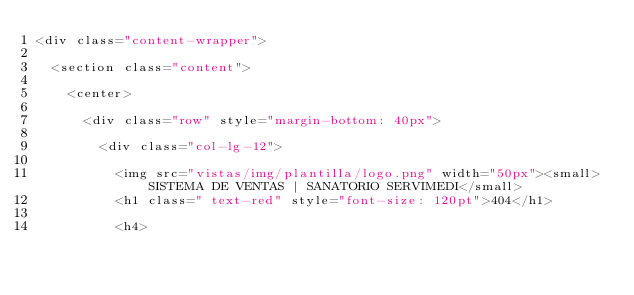<code> <loc_0><loc_0><loc_500><loc_500><_PHP_><div class="content-wrapper">

  <section class="content">

    <center>

      <div class="row" style="margin-bottom: 40px">

        <div class="col-lg-12">

          <img src="vistas/img/plantilla/logo.png" width="50px"><small> SISTEMA DE VENTAS | SANATORIO SERVIMEDI</small>
          <h1 class=" text-red" style="font-size: 120pt">404</h1>

          <h4>
</code> 